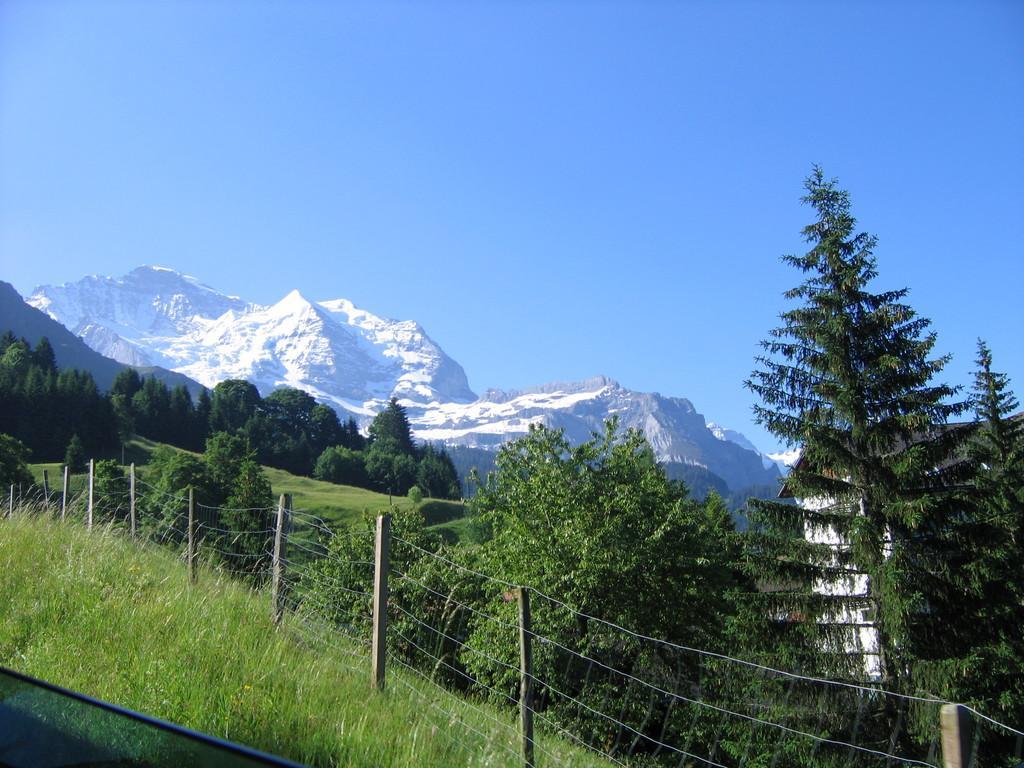Please provide a concise description of this image. In this image we can see the mountains, hills, trees, grass and also the fence. We can also see the sky. 